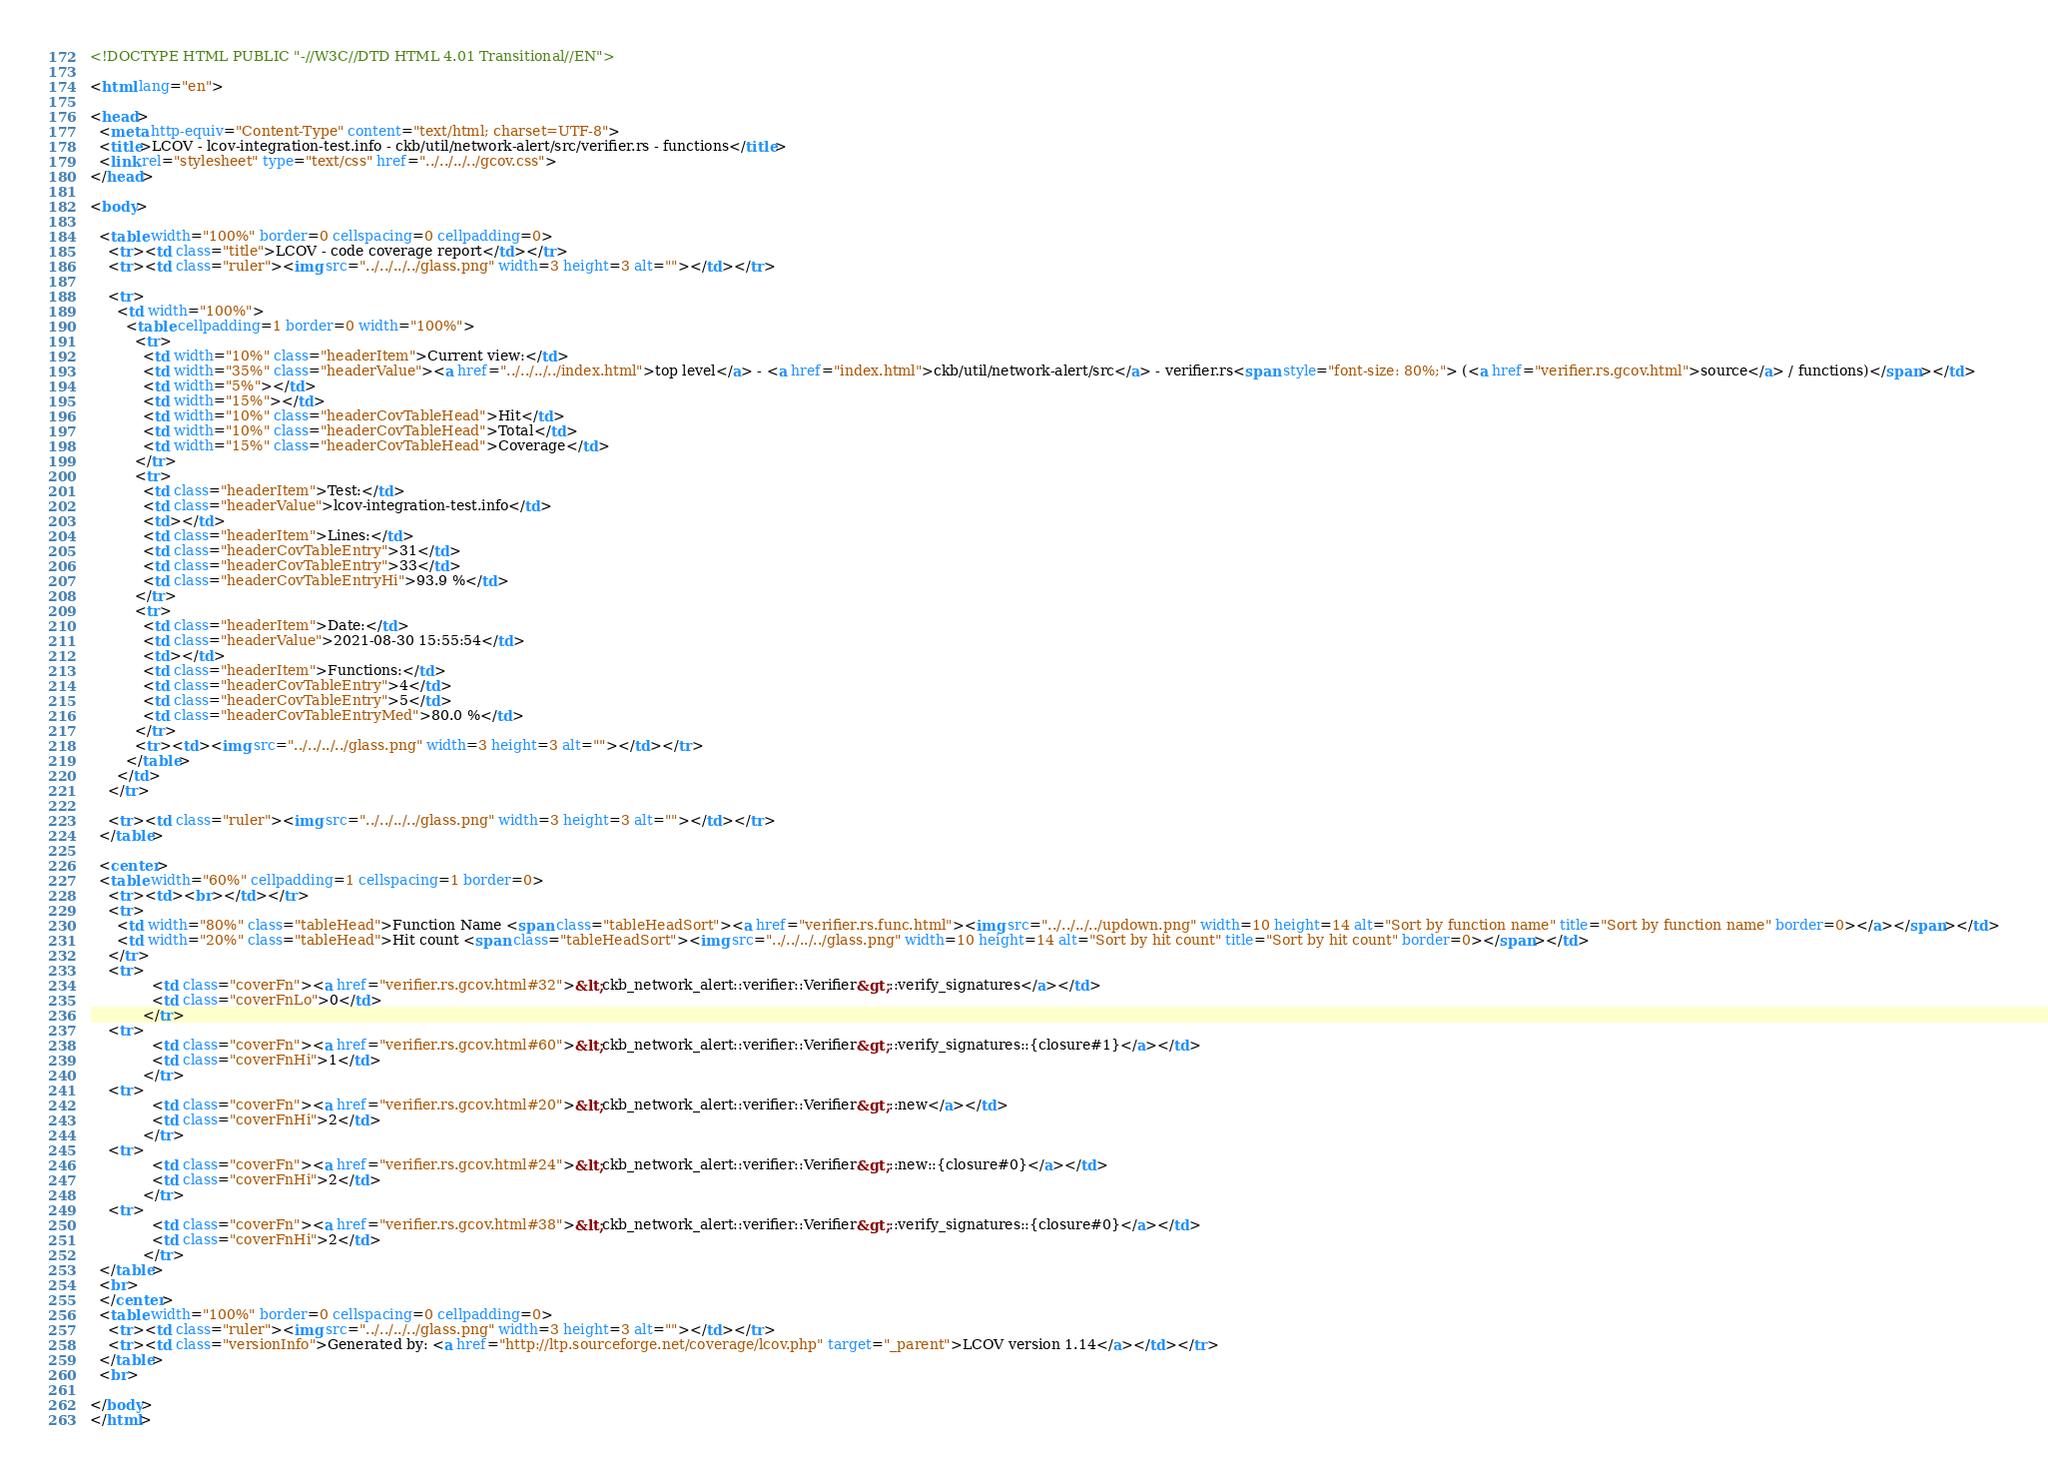Convert code to text. <code><loc_0><loc_0><loc_500><loc_500><_HTML_><!DOCTYPE HTML PUBLIC "-//W3C//DTD HTML 4.01 Transitional//EN">

<html lang="en">

<head>
  <meta http-equiv="Content-Type" content="text/html; charset=UTF-8">
  <title>LCOV - lcov-integration-test.info - ckb/util/network-alert/src/verifier.rs - functions</title>
  <link rel="stylesheet" type="text/css" href="../../../../gcov.css">
</head>

<body>

  <table width="100%" border=0 cellspacing=0 cellpadding=0>
    <tr><td class="title">LCOV - code coverage report</td></tr>
    <tr><td class="ruler"><img src="../../../../glass.png" width=3 height=3 alt=""></td></tr>

    <tr>
      <td width="100%">
        <table cellpadding=1 border=0 width="100%">
          <tr>
            <td width="10%" class="headerItem">Current view:</td>
            <td width="35%" class="headerValue"><a href="../../../../index.html">top level</a> - <a href="index.html">ckb/util/network-alert/src</a> - verifier.rs<span style="font-size: 80%;"> (<a href="verifier.rs.gcov.html">source</a> / functions)</span></td>
            <td width="5%"></td>
            <td width="15%"></td>
            <td width="10%" class="headerCovTableHead">Hit</td>
            <td width="10%" class="headerCovTableHead">Total</td>
            <td width="15%" class="headerCovTableHead">Coverage</td>
          </tr>
          <tr>
            <td class="headerItem">Test:</td>
            <td class="headerValue">lcov-integration-test.info</td>
            <td></td>
            <td class="headerItem">Lines:</td>
            <td class="headerCovTableEntry">31</td>
            <td class="headerCovTableEntry">33</td>
            <td class="headerCovTableEntryHi">93.9 %</td>
          </tr>
          <tr>
            <td class="headerItem">Date:</td>
            <td class="headerValue">2021-08-30 15:55:54</td>
            <td></td>
            <td class="headerItem">Functions:</td>
            <td class="headerCovTableEntry">4</td>
            <td class="headerCovTableEntry">5</td>
            <td class="headerCovTableEntryMed">80.0 %</td>
          </tr>
          <tr><td><img src="../../../../glass.png" width=3 height=3 alt=""></td></tr>
        </table>
      </td>
    </tr>

    <tr><td class="ruler"><img src="../../../../glass.png" width=3 height=3 alt=""></td></tr>
  </table>

  <center>
  <table width="60%" cellpadding=1 cellspacing=1 border=0>
    <tr><td><br></td></tr>
    <tr>
      <td width="80%" class="tableHead">Function Name <span class="tableHeadSort"><a href="verifier.rs.func.html"><img src="../../../../updown.png" width=10 height=14 alt="Sort by function name" title="Sort by function name" border=0></a></span></td>
      <td width="20%" class="tableHead">Hit count <span class="tableHeadSort"><img src="../../../../glass.png" width=10 height=14 alt="Sort by hit count" title="Sort by hit count" border=0></span></td>
    </tr>
    <tr>
              <td class="coverFn"><a href="verifier.rs.gcov.html#32">&lt;ckb_network_alert::verifier::Verifier&gt;::verify_signatures</a></td>
              <td class="coverFnLo">0</td>
            </tr>
    <tr>
              <td class="coverFn"><a href="verifier.rs.gcov.html#60">&lt;ckb_network_alert::verifier::Verifier&gt;::verify_signatures::{closure#1}</a></td>
              <td class="coverFnHi">1</td>
            </tr>
    <tr>
              <td class="coverFn"><a href="verifier.rs.gcov.html#20">&lt;ckb_network_alert::verifier::Verifier&gt;::new</a></td>
              <td class="coverFnHi">2</td>
            </tr>
    <tr>
              <td class="coverFn"><a href="verifier.rs.gcov.html#24">&lt;ckb_network_alert::verifier::Verifier&gt;::new::{closure#0}</a></td>
              <td class="coverFnHi">2</td>
            </tr>
    <tr>
              <td class="coverFn"><a href="verifier.rs.gcov.html#38">&lt;ckb_network_alert::verifier::Verifier&gt;::verify_signatures::{closure#0}</a></td>
              <td class="coverFnHi">2</td>
            </tr>
  </table>
  <br>
  </center>
  <table width="100%" border=0 cellspacing=0 cellpadding=0>
    <tr><td class="ruler"><img src="../../../../glass.png" width=3 height=3 alt=""></td></tr>
    <tr><td class="versionInfo">Generated by: <a href="http://ltp.sourceforge.net/coverage/lcov.php" target="_parent">LCOV version 1.14</a></td></tr>
  </table>
  <br>

</body>
</html>
</code> 